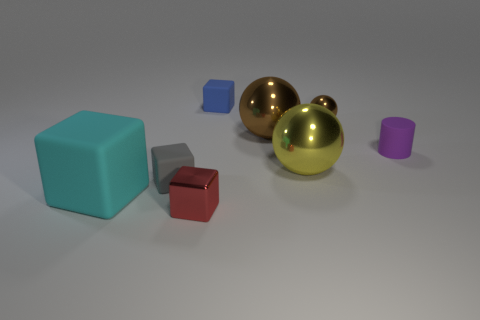Add 1 big brown balls. How many objects exist? 9 Subtract all large yellow spheres. How many spheres are left? 2 Subtract all cyan cubes. How many cubes are left? 3 Subtract all cylinders. How many objects are left? 7 Subtract all brown spheres. Subtract all purple blocks. How many spheres are left? 1 Subtract all green cubes. How many yellow spheres are left? 1 Subtract all red things. Subtract all purple matte cylinders. How many objects are left? 6 Add 5 small blocks. How many small blocks are left? 8 Add 6 small cylinders. How many small cylinders exist? 7 Subtract 2 brown spheres. How many objects are left? 6 